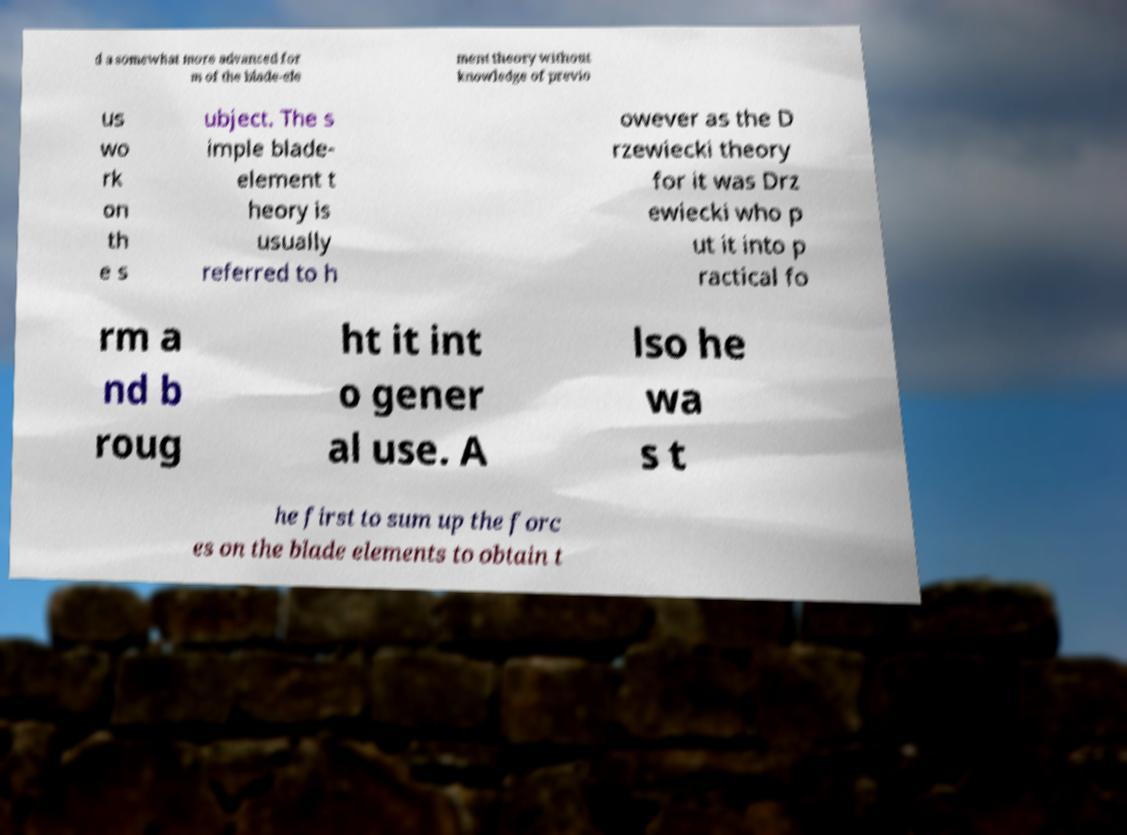There's text embedded in this image that I need extracted. Can you transcribe it verbatim? d a somewhat more advanced for m of the blade-ele ment theory without knowledge of previo us wo rk on th e s ubject. The s imple blade- element t heory is usually referred to h owever as the D rzewiecki theory for it was Drz ewiecki who p ut it into p ractical fo rm a nd b roug ht it int o gener al use. A lso he wa s t he first to sum up the forc es on the blade elements to obtain t 